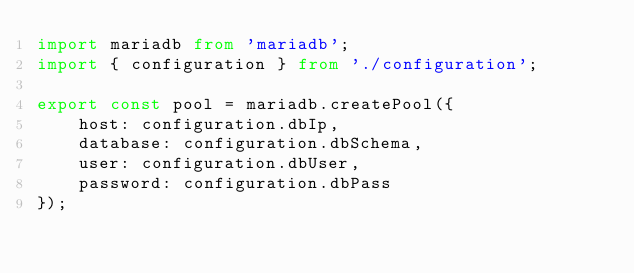<code> <loc_0><loc_0><loc_500><loc_500><_TypeScript_>import mariadb from 'mariadb';
import { configuration } from './configuration';

export const pool = mariadb.createPool({
    host: configuration.dbIp,
    database: configuration.dbSchema,
    user: configuration.dbUser,
    password: configuration.dbPass
});</code> 